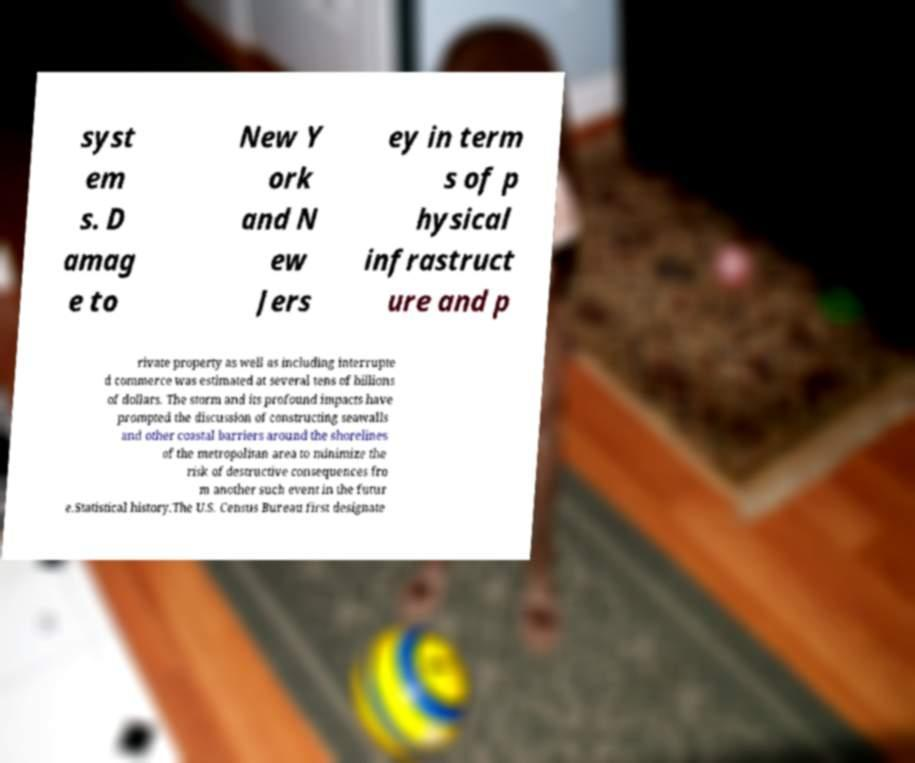Can you read and provide the text displayed in the image?This photo seems to have some interesting text. Can you extract and type it out for me? syst em s. D amag e to New Y ork and N ew Jers ey in term s of p hysical infrastruct ure and p rivate property as well as including interrupte d commerce was estimated at several tens of billions of dollars. The storm and its profound impacts have prompted the discussion of constructing seawalls and other coastal barriers around the shorelines of the metropolitan area to minimize the risk of destructive consequences fro m another such event in the futur e.Statistical history.The U.S. Census Bureau first designate 